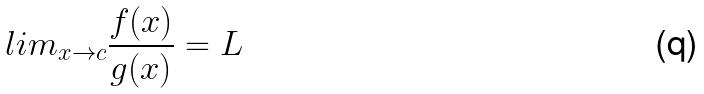Convert formula to latex. <formula><loc_0><loc_0><loc_500><loc_500>l i m _ { x \rightarrow c } \frac { f ( x ) } { g ( x ) } = L</formula> 